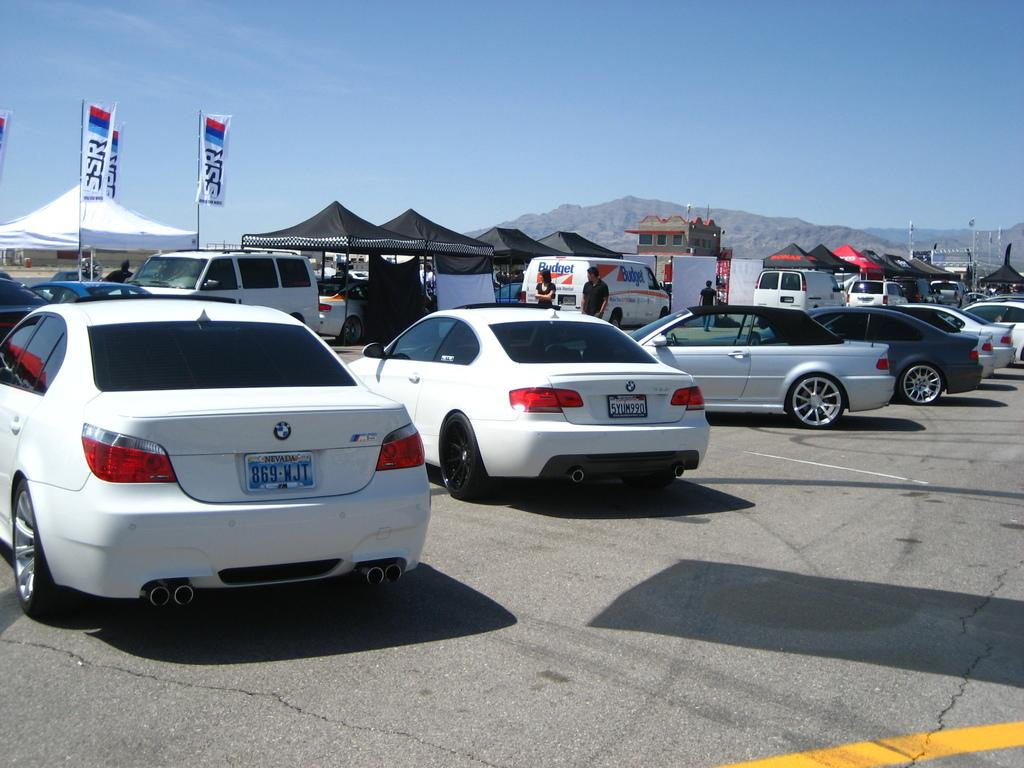What can be seen in the foreground of the image? There are cars on the road in the foreground of the image. What types of vehicles can be seen in the background of the image? Cars and vans can be seen in the background of the image. What additional structures or objects are present in the background of the image? Tents, flags, poles, boards, a building, mountains, and sky are visible in the background of the image. Can you describe the weather condition in the image? The presence of a cloud in the sky suggests that there might be some clouds in the sky, but the weather condition cannot be determined definitively. What type of orange is being offered to the cars in the image? There is no orange or offer present in the image; it features cars on the road and various structures and objects in the background. How much debt is visible in the image? There is no reference to debt in the image, so it cannot be determined from the image. 